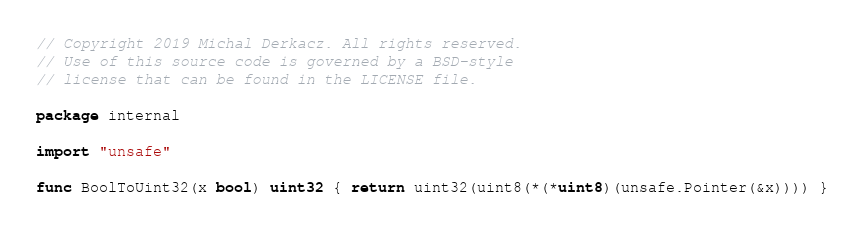<code> <loc_0><loc_0><loc_500><loc_500><_Go_>// Copyright 2019 Michal Derkacz. All rights reserved.
// Use of this source code is governed by a BSD-style
// license that can be found in the LICENSE file.

package internal

import "unsafe"

func BoolToUint32(x bool) uint32 { return uint32(uint8(*(*uint8)(unsafe.Pointer(&x)))) }
</code> 